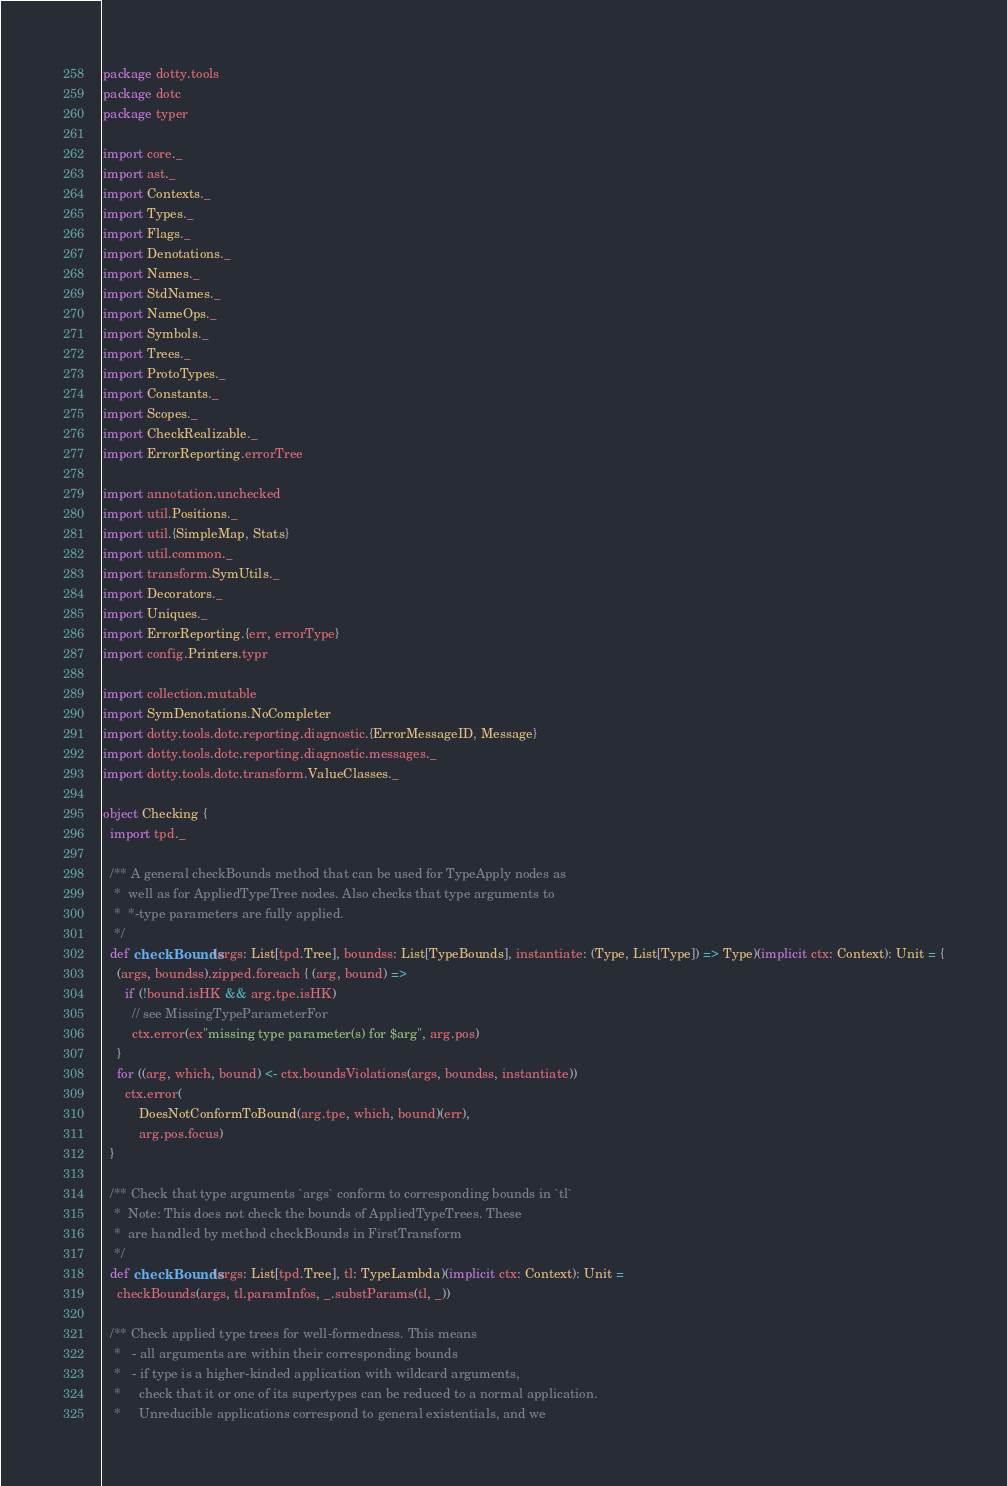<code> <loc_0><loc_0><loc_500><loc_500><_Scala_>package dotty.tools
package dotc
package typer

import core._
import ast._
import Contexts._
import Types._
import Flags._
import Denotations._
import Names._
import StdNames._
import NameOps._
import Symbols._
import Trees._
import ProtoTypes._
import Constants._
import Scopes._
import CheckRealizable._
import ErrorReporting.errorTree

import annotation.unchecked
import util.Positions._
import util.{SimpleMap, Stats}
import util.common._
import transform.SymUtils._
import Decorators._
import Uniques._
import ErrorReporting.{err, errorType}
import config.Printers.typr

import collection.mutable
import SymDenotations.NoCompleter
import dotty.tools.dotc.reporting.diagnostic.{ErrorMessageID, Message}
import dotty.tools.dotc.reporting.diagnostic.messages._
import dotty.tools.dotc.transform.ValueClasses._

object Checking {
  import tpd._

  /** A general checkBounds method that can be used for TypeApply nodes as
   *  well as for AppliedTypeTree nodes. Also checks that type arguments to
   *  *-type parameters are fully applied.
   */
  def checkBounds(args: List[tpd.Tree], boundss: List[TypeBounds], instantiate: (Type, List[Type]) => Type)(implicit ctx: Context): Unit = {
    (args, boundss).zipped.foreach { (arg, bound) =>
      if (!bound.isHK && arg.tpe.isHK)
        // see MissingTypeParameterFor
        ctx.error(ex"missing type parameter(s) for $arg", arg.pos)
    }
    for ((arg, which, bound) <- ctx.boundsViolations(args, boundss, instantiate))
      ctx.error(
          DoesNotConformToBound(arg.tpe, which, bound)(err),
          arg.pos.focus)
  }

  /** Check that type arguments `args` conform to corresponding bounds in `tl`
   *  Note: This does not check the bounds of AppliedTypeTrees. These
   *  are handled by method checkBounds in FirstTransform
   */
  def checkBounds(args: List[tpd.Tree], tl: TypeLambda)(implicit ctx: Context): Unit =
    checkBounds(args, tl.paramInfos, _.substParams(tl, _))

  /** Check applied type trees for well-formedness. This means
   *   - all arguments are within their corresponding bounds
   *   - if type is a higher-kinded application with wildcard arguments,
   *     check that it or one of its supertypes can be reduced to a normal application.
   *     Unreducible applications correspond to general existentials, and we</code> 